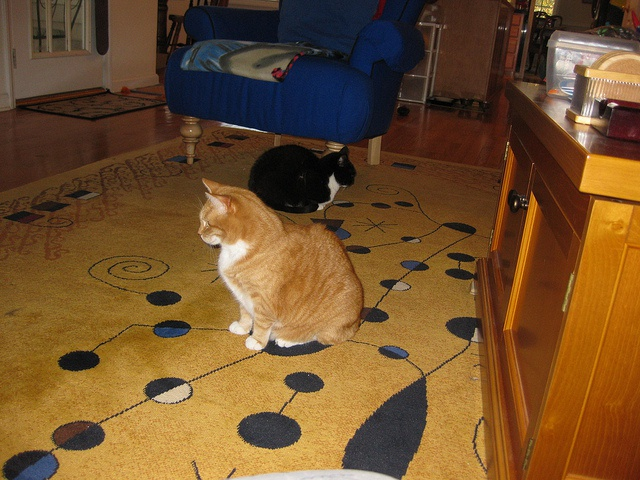Describe the objects in this image and their specific colors. I can see chair in black, navy, and gray tones, cat in black, olive, and tan tones, cat in black, darkgray, maroon, and gray tones, and chair in black, gray, and darkgreen tones in this image. 